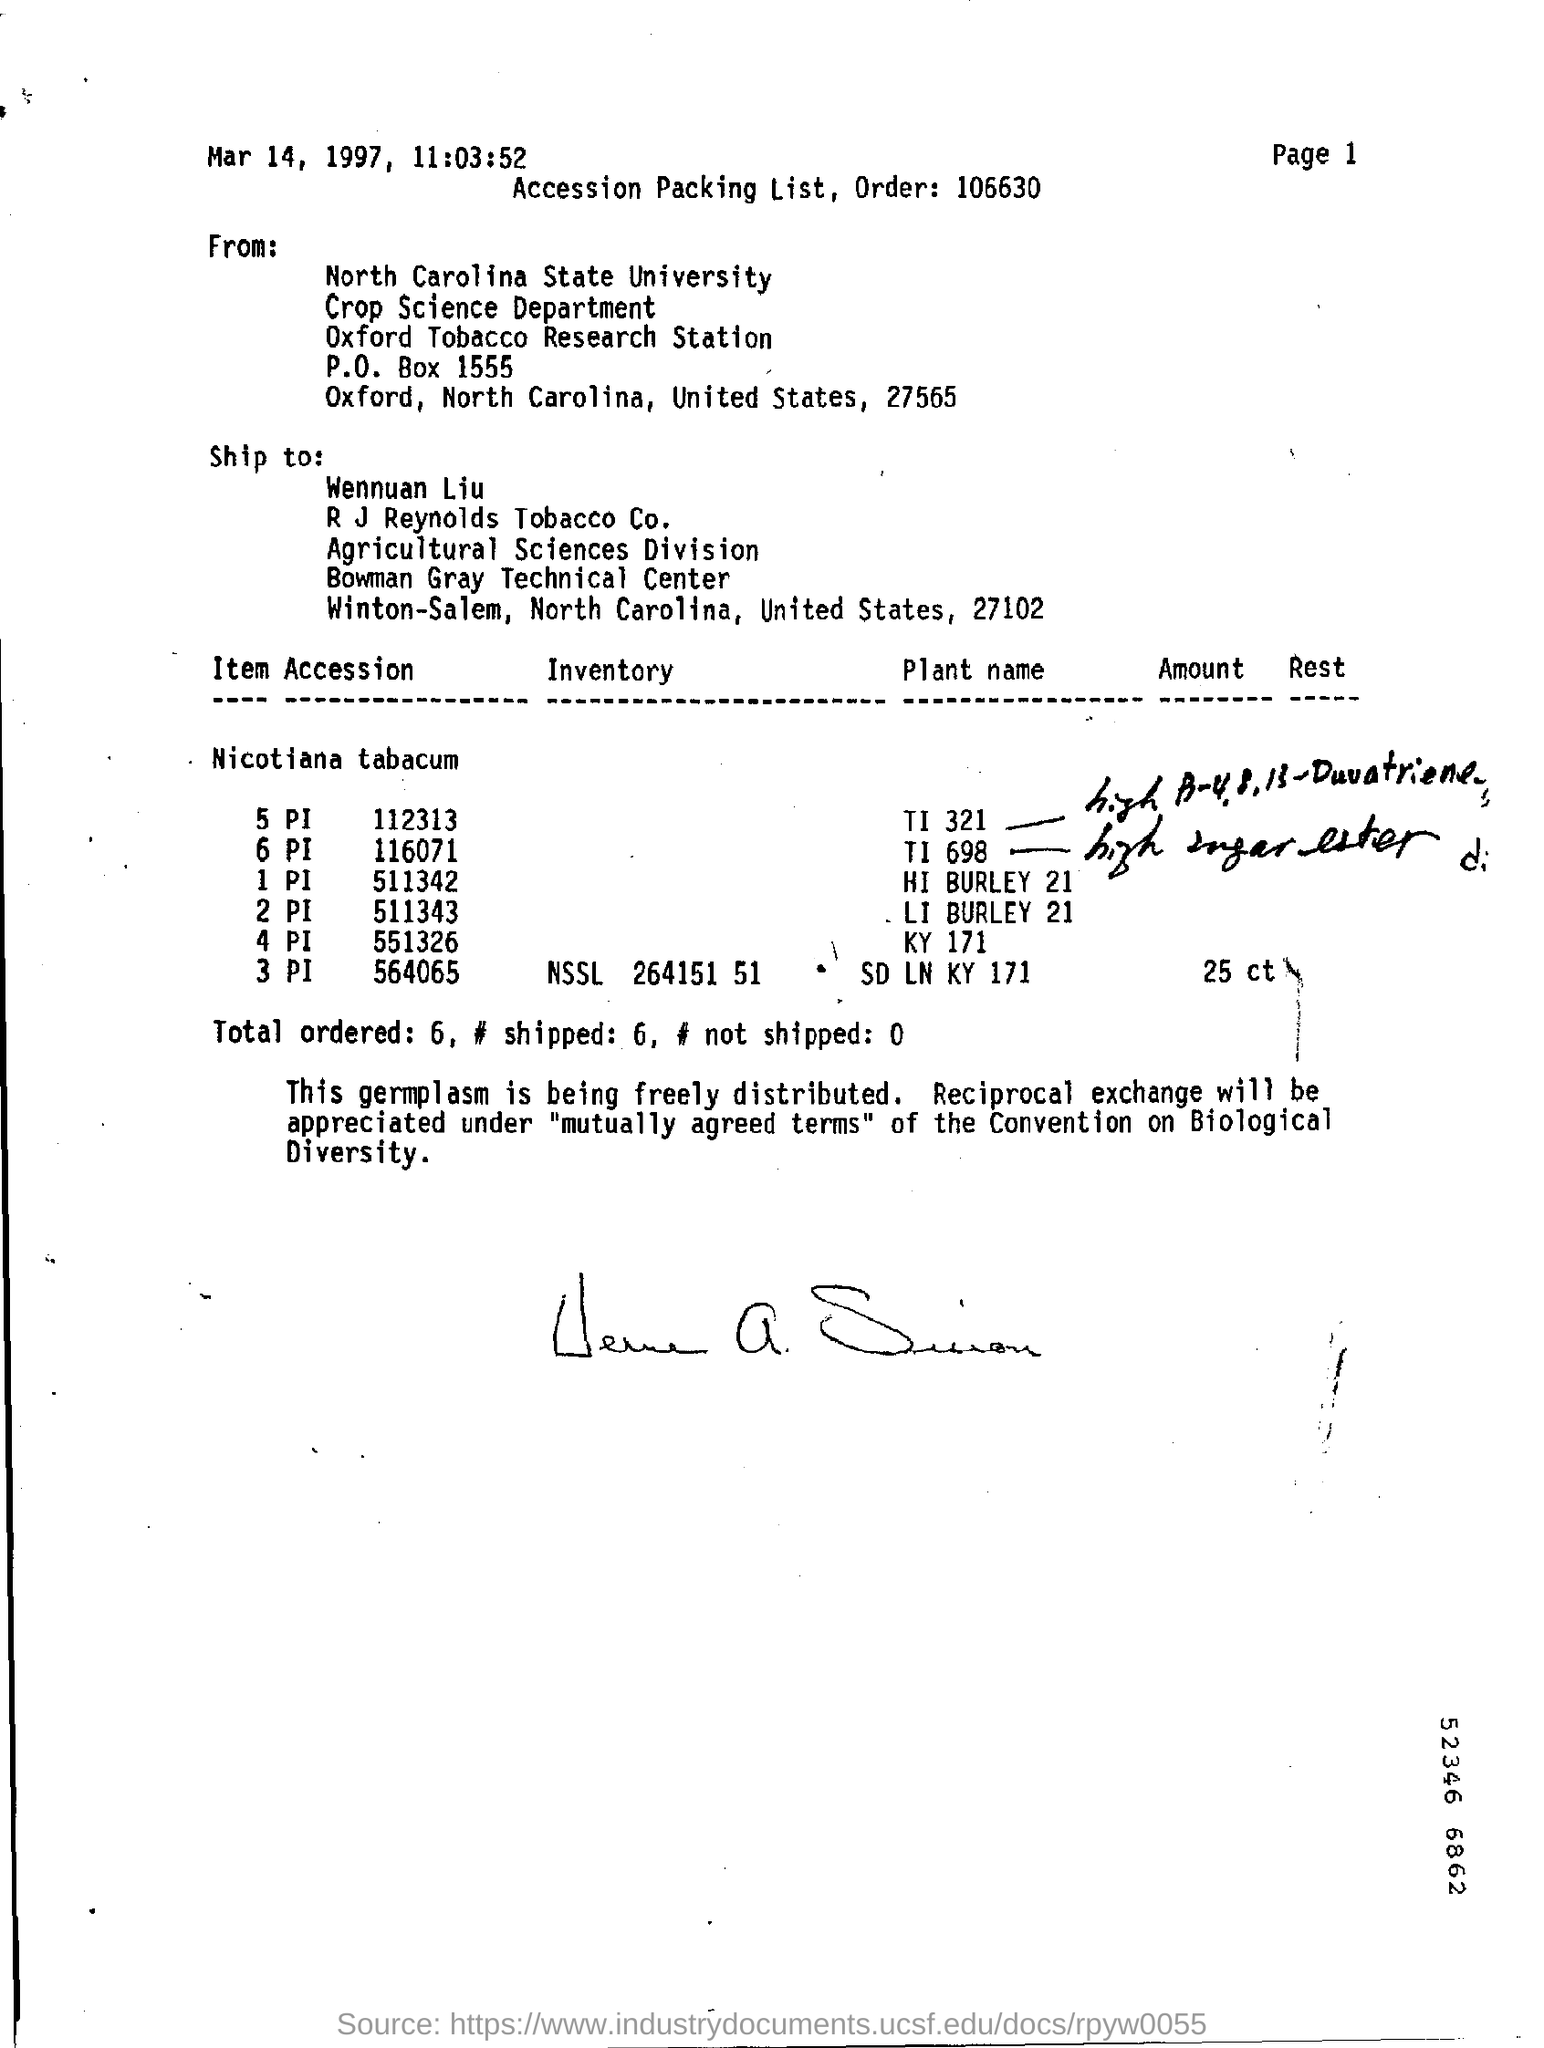What  is the date mentioned ?
Give a very brief answer. Mar 14, 1997. What is the time mentioned ?
Provide a short and direct response. 11:03:52. This is shipped to whom ?
Your answer should be very brief. Wennuan Liu. From whom this was sent ?
Offer a terse response. North Carolina State University. How many are shipped ?
Keep it short and to the point. 6. 